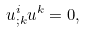Convert formula to latex. <formula><loc_0><loc_0><loc_500><loc_500>u ^ { i } _ { ; k } u ^ { k } = 0 ,</formula> 